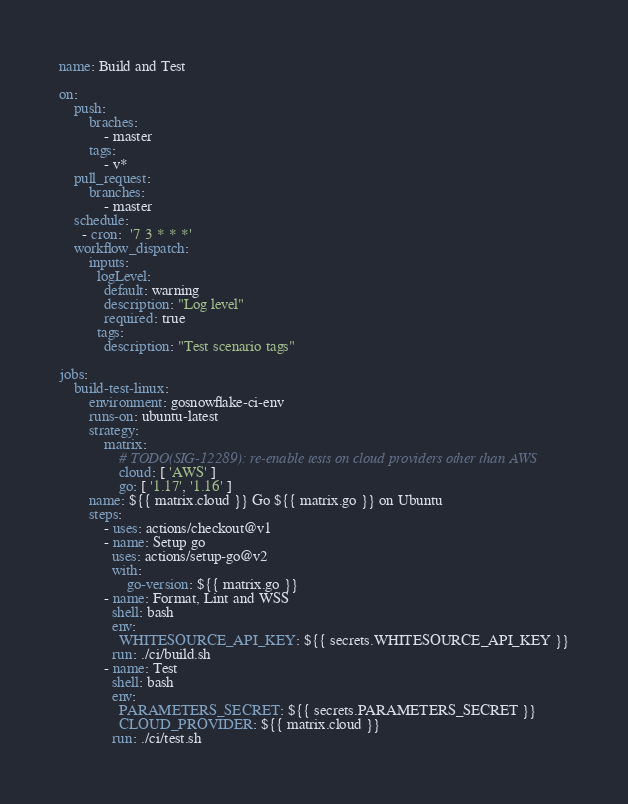Convert code to text. <code><loc_0><loc_0><loc_500><loc_500><_YAML_>name: Build and Test

on:
    push:
        braches:
            - master
        tags:
            - v*
    pull_request:
        branches:
            - master
    schedule:
      - cron:  '7 3 * * *'
    workflow_dispatch:
        inputs:
          logLevel:
            default: warning
            description: "Log level"
            required: true
          tags:
            description: "Test scenario tags"

jobs:
    build-test-linux:
        environment: gosnowflake-ci-env
        runs-on: ubuntu-latest
        strategy:
            matrix:
                # TODO(SIG-12289): re-enable tests on cloud providers other than AWS
                cloud: [ 'AWS' ]
                go: [ '1.17', '1.16' ]
        name: ${{ matrix.cloud }} Go ${{ matrix.go }} on Ubuntu
        steps:
            - uses: actions/checkout@v1
            - name: Setup go
              uses: actions/setup-go@v2
              with:
                  go-version: ${{ matrix.go }}
            - name: Format, Lint and WSS
              shell: bash
              env:
                WHITESOURCE_API_KEY: ${{ secrets.WHITESOURCE_API_KEY }}
              run: ./ci/build.sh
            - name: Test
              shell: bash
              env:
                PARAMETERS_SECRET: ${{ secrets.PARAMETERS_SECRET }}
                CLOUD_PROVIDER: ${{ matrix.cloud }}
              run: ./ci/test.sh
</code> 